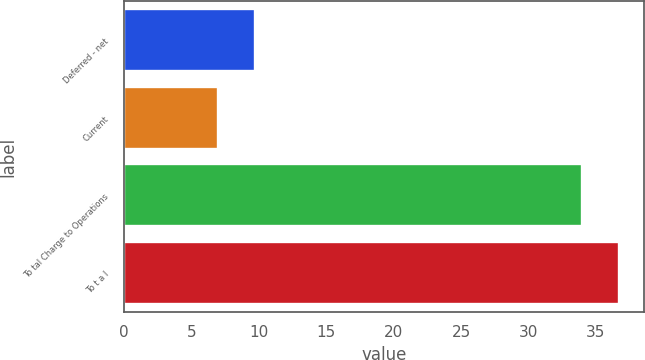Convert chart to OTSL. <chart><loc_0><loc_0><loc_500><loc_500><bar_chart><fcel>Deferred - net<fcel>Current<fcel>To tal Charge to Operations<fcel>To t a l<nl><fcel>9.7<fcel>7<fcel>34<fcel>36.7<nl></chart> 